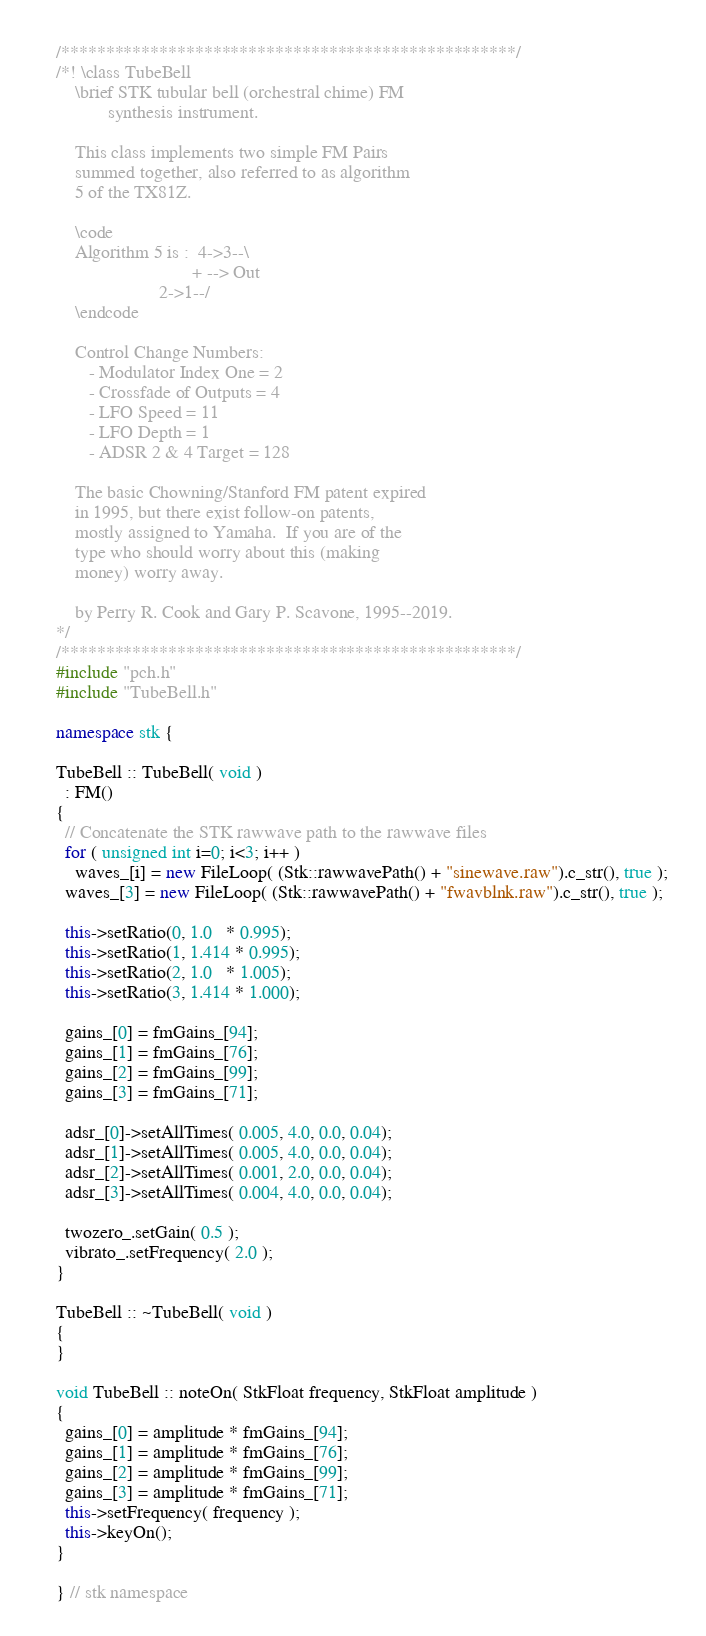<code> <loc_0><loc_0><loc_500><loc_500><_C++_>/***************************************************/
/*! \class TubeBell
    \brief STK tubular bell (orchestral chime) FM
           synthesis instrument.

    This class implements two simple FM Pairs
    summed together, also referred to as algorithm
    5 of the TX81Z.

    \code
    Algorithm 5 is :  4->3--\
                             + --> Out
                      2->1--/
    \endcode

    Control Change Numbers: 
       - Modulator Index One = 2
       - Crossfade of Outputs = 4
       - LFO Speed = 11
       - LFO Depth = 1
       - ADSR 2 & 4 Target = 128

    The basic Chowning/Stanford FM patent expired
    in 1995, but there exist follow-on patents,
    mostly assigned to Yamaha.  If you are of the
    type who should worry about this (making
    money) worry away.

    by Perry R. Cook and Gary P. Scavone, 1995--2019.
*/
/***************************************************/
#include "pch.h" 
#include "TubeBell.h"

namespace stk {

TubeBell :: TubeBell( void )
  : FM()
{
  // Concatenate the STK rawwave path to the rawwave files
  for ( unsigned int i=0; i<3; i++ )
    waves_[i] = new FileLoop( (Stk::rawwavePath() + "sinewave.raw").c_str(), true );
  waves_[3] = new FileLoop( (Stk::rawwavePath() + "fwavblnk.raw").c_str(), true );

  this->setRatio(0, 1.0   * 0.995);
  this->setRatio(1, 1.414 * 0.995);
  this->setRatio(2, 1.0   * 1.005);
  this->setRatio(3, 1.414 * 1.000);

  gains_[0] = fmGains_[94];
  gains_[1] = fmGains_[76];
  gains_[2] = fmGains_[99];
  gains_[3] = fmGains_[71];

  adsr_[0]->setAllTimes( 0.005, 4.0, 0.0, 0.04);
  adsr_[1]->setAllTimes( 0.005, 4.0, 0.0, 0.04);
  adsr_[2]->setAllTimes( 0.001, 2.0, 0.0, 0.04);
  adsr_[3]->setAllTimes( 0.004, 4.0, 0.0, 0.04);

  twozero_.setGain( 0.5 );
  vibrato_.setFrequency( 2.0 );
}  

TubeBell :: ~TubeBell( void )
{
}

void TubeBell :: noteOn( StkFloat frequency, StkFloat amplitude )
{
  gains_[0] = amplitude * fmGains_[94];
  gains_[1] = amplitude * fmGains_[76];
  gains_[2] = amplitude * fmGains_[99];
  gains_[3] = amplitude * fmGains_[71];
  this->setFrequency( frequency );
  this->keyOn();
}

} // stk namespace
</code> 